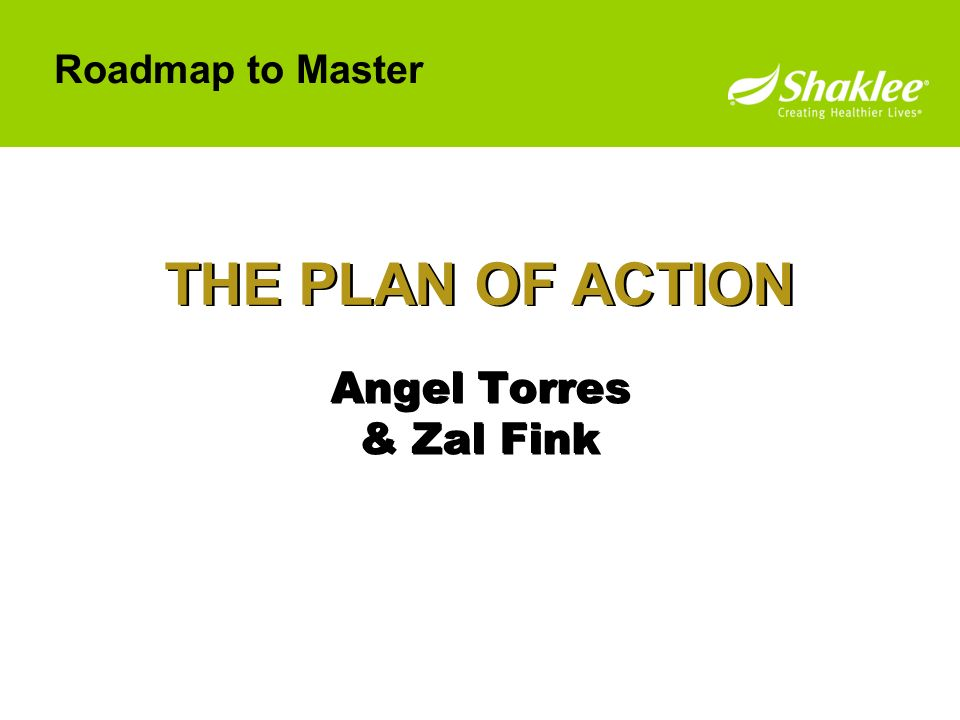What details can suggest if this slide is from a larger presentation or a standalone document? The slide appears to be part of a larger presentation, as indicated by several clues. Firstly, the structured layout featuring a title—'THE PLAN OF ACTION'—implies that this is one segment within a broader discussion. The presence of names, 'Angel Torres & Zal Fink,' further suggests contributors or presenters, which is common in a multi-slide presentation. Additionally, the design follows conventions typical of PowerPoint presentations, used often in corporate and organizational settings. Although there is no visible slide number, which is typically included in a sequence, its absence does not conclusively indicate it is standalone. Thus, the structured, professional format and content imply it is likely part of a more extensive presentation. 